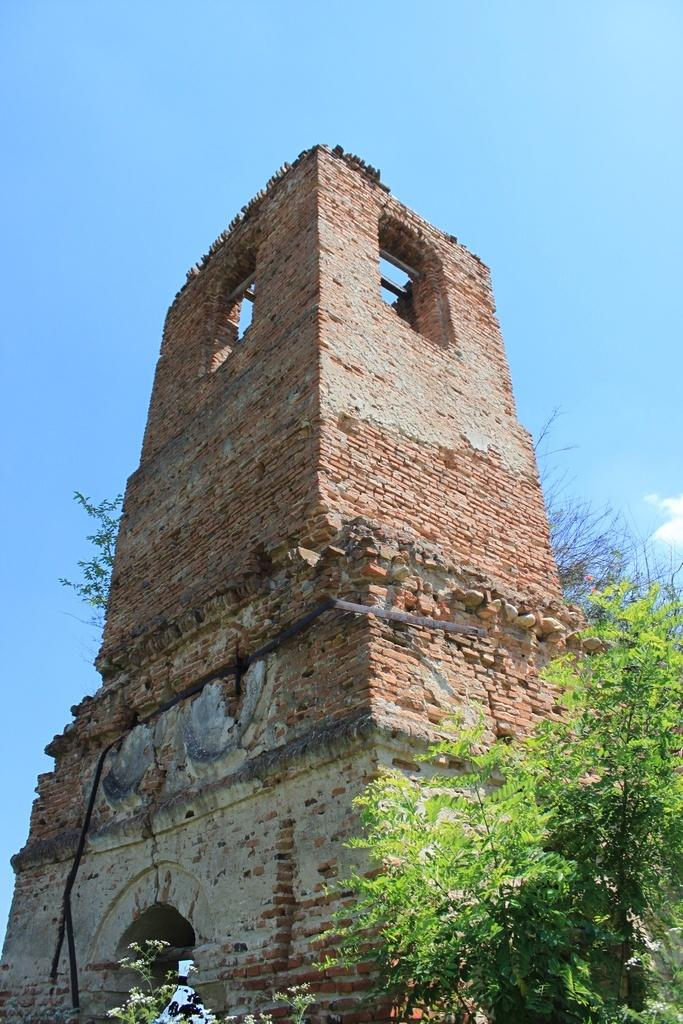What type of structure is present in the picture? There is a building in the picture. What other natural elements can be seen in the picture? There are trees in the picture. What can be seen in the distance in the picture? The sky is visible in the background of the picture. What rule is being enforced in the class depicted in the image? There is no class or rule present in the image; it features a building and trees with the sky visible in the background. 